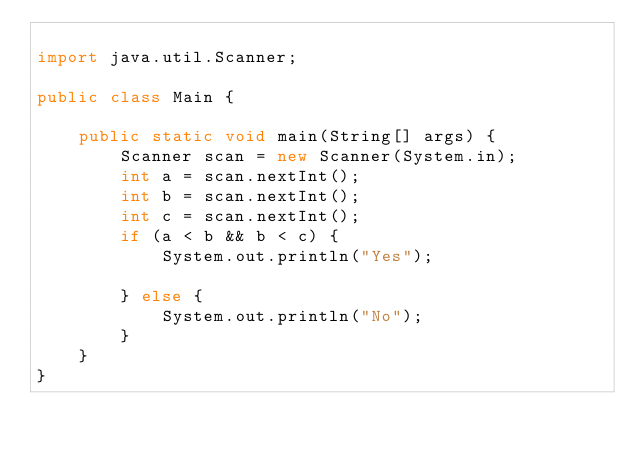Convert code to text. <code><loc_0><loc_0><loc_500><loc_500><_Java_>
import java.util.Scanner;

public class Main {

    public static void main(String[] args) {
        Scanner scan = new Scanner(System.in);
        int a = scan.nextInt();
        int b = scan.nextInt();
        int c = scan.nextInt();
        if (a < b && b < c) {
            System.out.println("Yes");

        } else {
            System.out.println("No");
        }
    }
}

</code> 